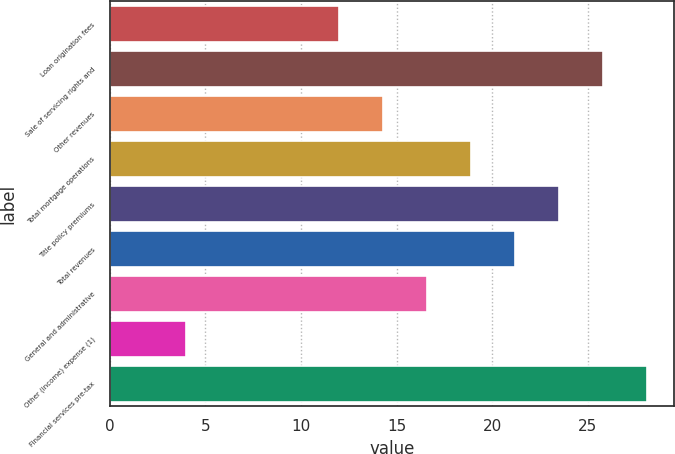Convert chart to OTSL. <chart><loc_0><loc_0><loc_500><loc_500><bar_chart><fcel>Loan origination fees<fcel>Sale of servicing rights and<fcel>Other revenues<fcel>Total mortgage operations<fcel>Title policy premiums<fcel>Total revenues<fcel>General and administrative<fcel>Other (income) expense (1)<fcel>Financial services pre-tax<nl><fcel>12<fcel>25.8<fcel>14.3<fcel>18.9<fcel>23.5<fcel>21.2<fcel>16.6<fcel>4<fcel>28.1<nl></chart> 